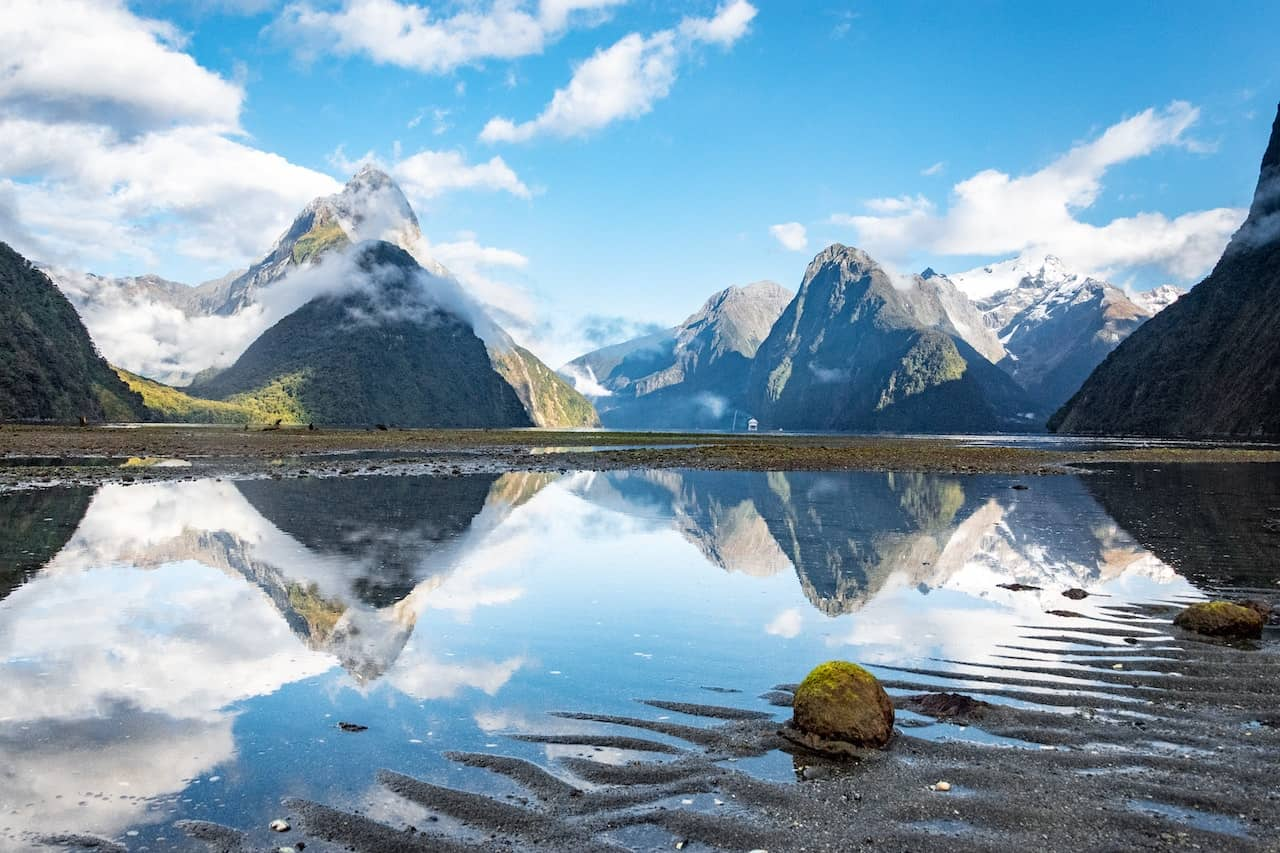Can you describe the geological features visible in this image and explain how they might have formed? The image prominently features steep, rugged mountains with sharp peaks, which are typical of glacial valleys. These geological formations likely developed through processes of glaciation, where glaciers carved through the rock over thousands of years, shaping the deep valleys and sharp mountain profiles we observe today. The presence of snow caps suggests high altitudes and cooler temperatures at the peaks, contributing to the ongoing cycle of erosion and deposition that shapes these landscapes. 